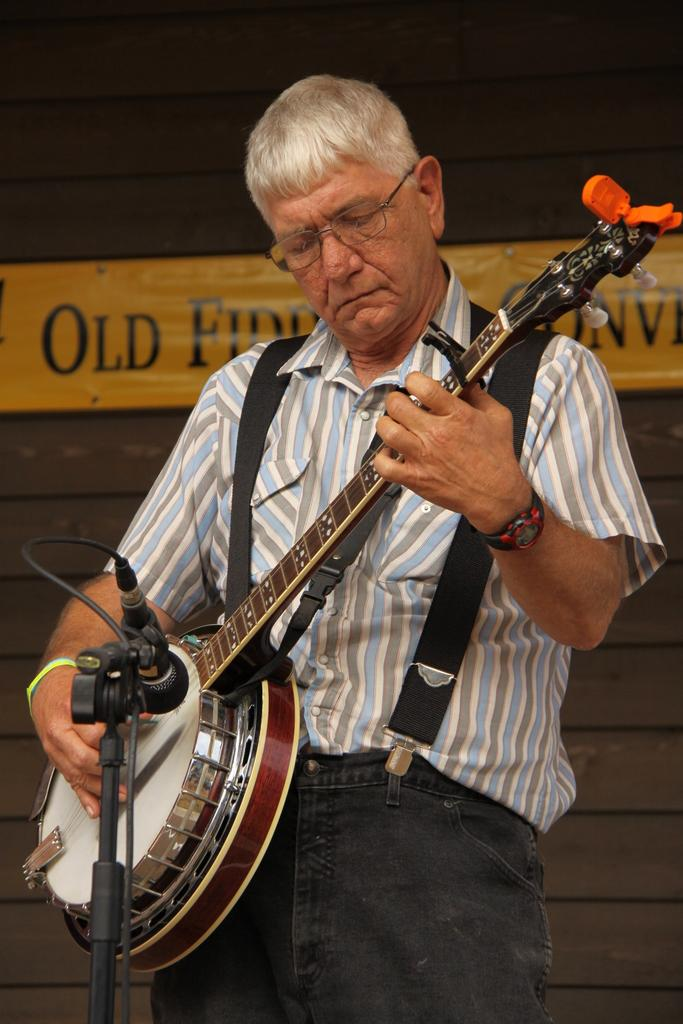What is the main subject of the image? The main subject of the image is a man. What is the man holding in the image? The man is holding a musical instrument. Can you describe the man's shirt in the image? The man is wearing a shirt with white, blue, and grey colors. What accessory is the man wearing in the image? The man has spectacles. What object is in front of the man in the image? There is a microphone in front of the man. What type of disease is the man suffering from in the image? There is no indication of any disease in the image; the man appears to be holding a musical instrument and standing in front of a microphone. Can you describe the rainstorm happening in the background of the image? There is no rainstorm present in the image; the background is not visible or described in the provided facts. 